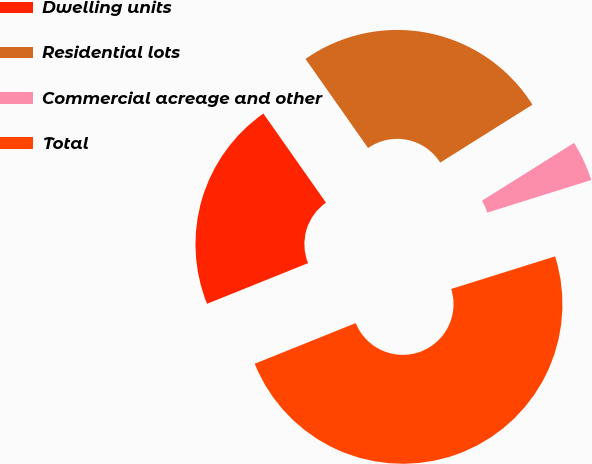Convert chart to OTSL. <chart><loc_0><loc_0><loc_500><loc_500><pie_chart><fcel>Dwelling units<fcel>Residential lots<fcel>Commercial acreage and other<fcel>Total<nl><fcel>21.35%<fcel>25.82%<fcel>4.09%<fcel>48.74%<nl></chart> 